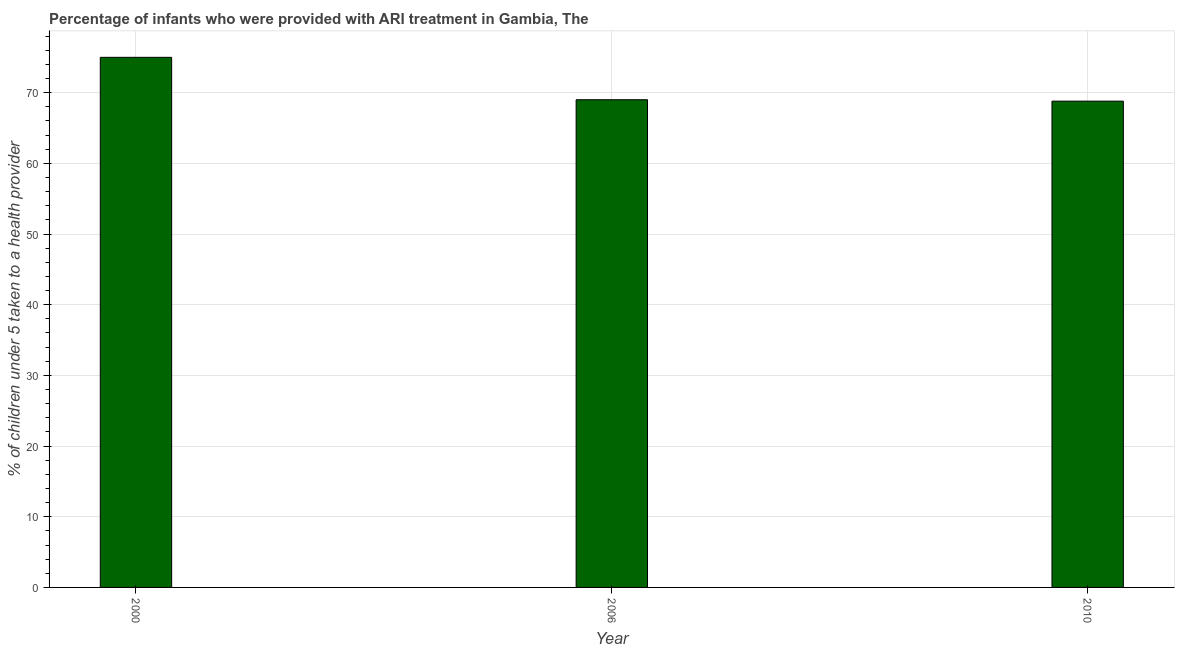Does the graph contain any zero values?
Your answer should be very brief. No. What is the title of the graph?
Provide a succinct answer. Percentage of infants who were provided with ARI treatment in Gambia, The. What is the label or title of the X-axis?
Offer a terse response. Year. What is the label or title of the Y-axis?
Your response must be concise. % of children under 5 taken to a health provider. What is the percentage of children who were provided with ari treatment in 2000?
Provide a short and direct response. 75. Across all years, what is the minimum percentage of children who were provided with ari treatment?
Your response must be concise. 68.8. In which year was the percentage of children who were provided with ari treatment maximum?
Provide a succinct answer. 2000. What is the sum of the percentage of children who were provided with ari treatment?
Provide a short and direct response. 212.8. What is the difference between the percentage of children who were provided with ari treatment in 2000 and 2006?
Keep it short and to the point. 6. What is the average percentage of children who were provided with ari treatment per year?
Keep it short and to the point. 70.93. Is the percentage of children who were provided with ari treatment in 2006 less than that in 2010?
Ensure brevity in your answer.  No. Are the values on the major ticks of Y-axis written in scientific E-notation?
Keep it short and to the point. No. What is the % of children under 5 taken to a health provider in 2010?
Keep it short and to the point. 68.8. What is the difference between the % of children under 5 taken to a health provider in 2000 and 2006?
Provide a succinct answer. 6. What is the difference between the % of children under 5 taken to a health provider in 2006 and 2010?
Offer a very short reply. 0.2. What is the ratio of the % of children under 5 taken to a health provider in 2000 to that in 2006?
Make the answer very short. 1.09. What is the ratio of the % of children under 5 taken to a health provider in 2000 to that in 2010?
Your response must be concise. 1.09. What is the ratio of the % of children under 5 taken to a health provider in 2006 to that in 2010?
Offer a terse response. 1. 